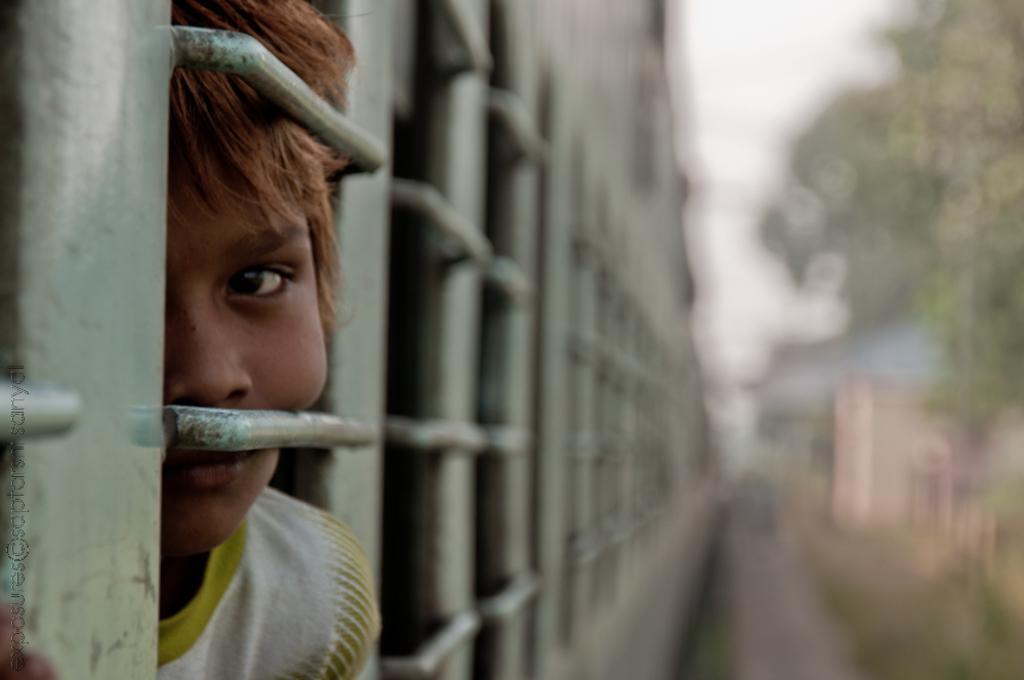How would you summarize this image in a sentence or two? In the foreground of this image, there is a kid inside a train near a window on the left and on the right, the image is blur. 